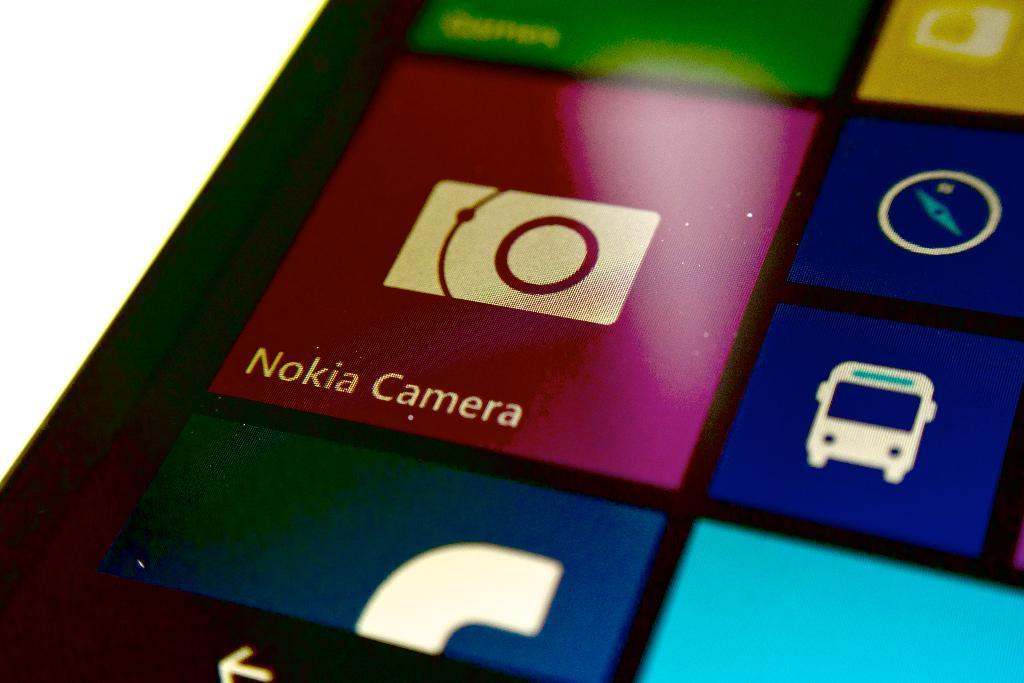<image>
Give a short and clear explanation of the subsequent image. A maroon icon shows a picture of a camera with Nokia Camera written underneath it. 